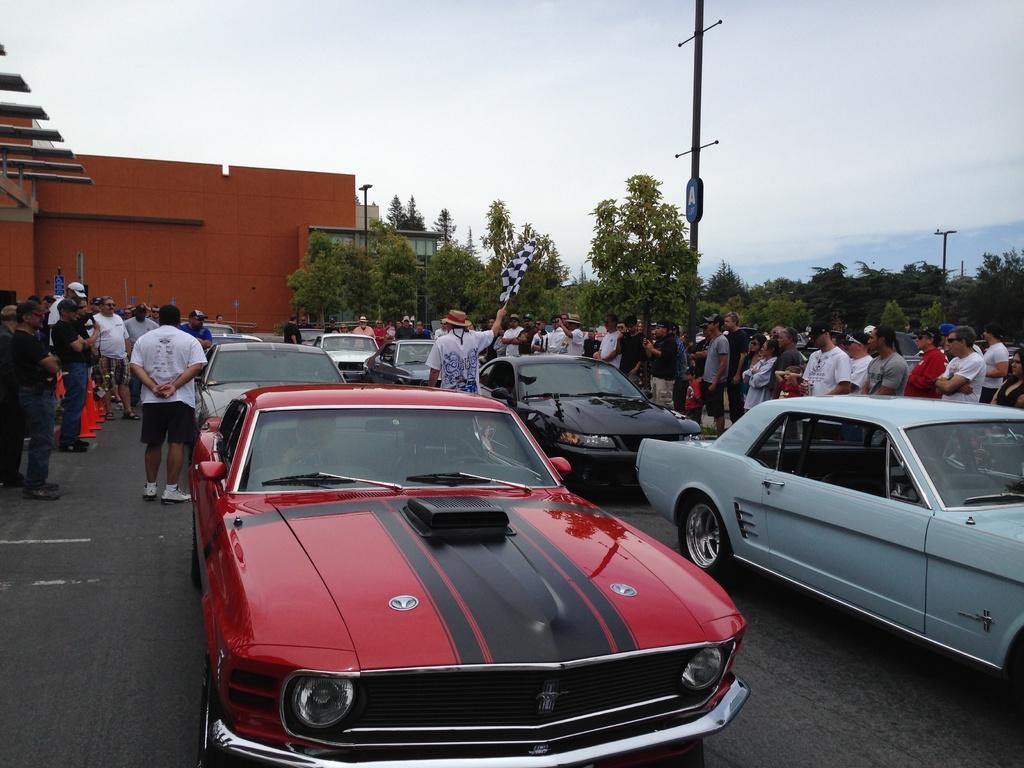Could you give a brief overview of what you see in this image? In the center of the image we can see a cars are present. In the background of the image we can see a trees, building, flagpoles are present. On the left and right side of the image some persons are there. At the top of the image sky is present. At the bottom of the image road is there. 